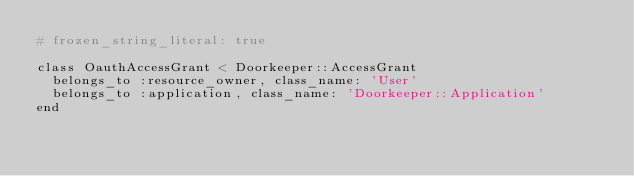<code> <loc_0><loc_0><loc_500><loc_500><_Ruby_># frozen_string_literal: true

class OauthAccessGrant < Doorkeeper::AccessGrant
  belongs_to :resource_owner, class_name: 'User'
  belongs_to :application, class_name: 'Doorkeeper::Application'
end
</code> 